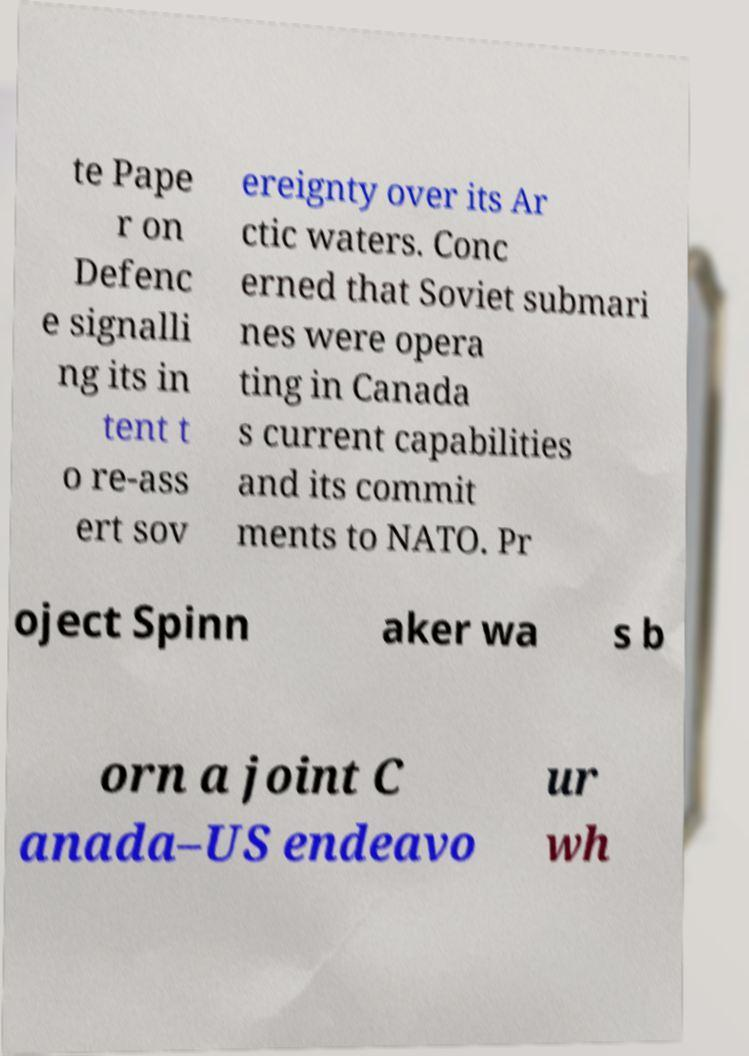Please identify and transcribe the text found in this image. te Pape r on Defenc e signalli ng its in tent t o re-ass ert sov ereignty over its Ar ctic waters. Conc erned that Soviet submari nes were opera ting in Canada s current capabilities and its commit ments to NATO. Pr oject Spinn aker wa s b orn a joint C anada–US endeavo ur wh 